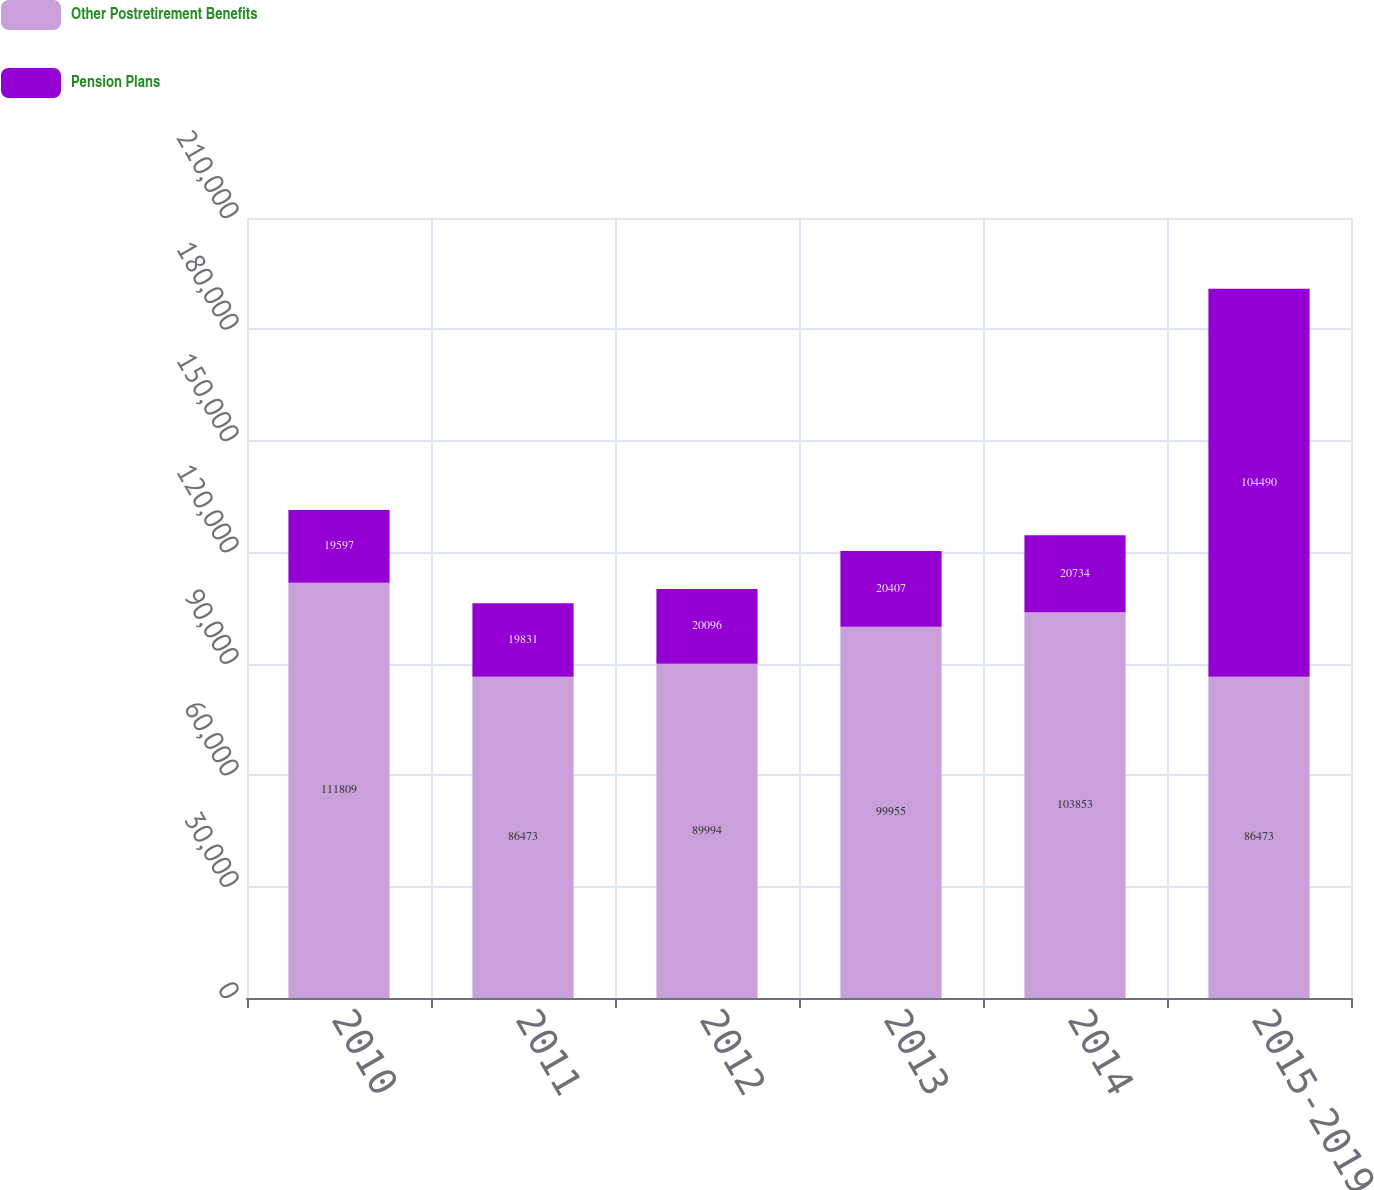Convert chart. <chart><loc_0><loc_0><loc_500><loc_500><stacked_bar_chart><ecel><fcel>2010<fcel>2011<fcel>2012<fcel>2013<fcel>2014<fcel>2015-2019<nl><fcel>Other Postretirement Benefits<fcel>111809<fcel>86473<fcel>89994<fcel>99955<fcel>103853<fcel>86473<nl><fcel>Pension Plans<fcel>19597<fcel>19831<fcel>20096<fcel>20407<fcel>20734<fcel>104490<nl></chart> 